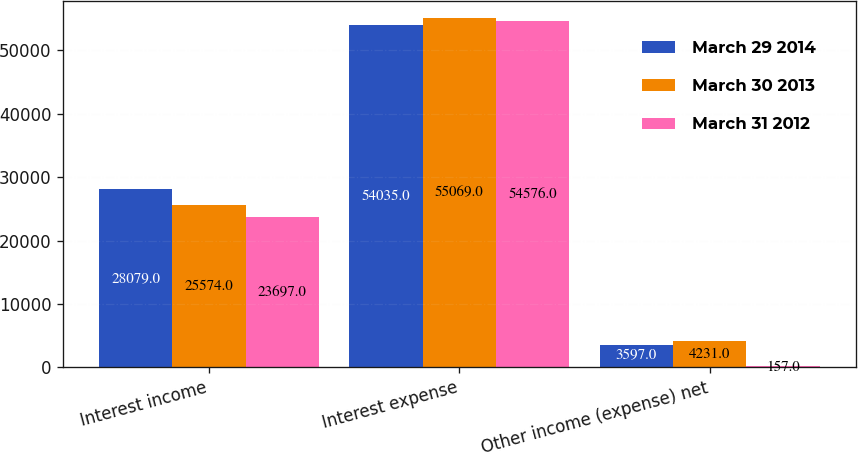Convert chart to OTSL. <chart><loc_0><loc_0><loc_500><loc_500><stacked_bar_chart><ecel><fcel>Interest income<fcel>Interest expense<fcel>Other income (expense) net<nl><fcel>March 29 2014<fcel>28079<fcel>54035<fcel>3597<nl><fcel>March 30 2013<fcel>25574<fcel>55069<fcel>4231<nl><fcel>March 31 2012<fcel>23697<fcel>54576<fcel>157<nl></chart> 